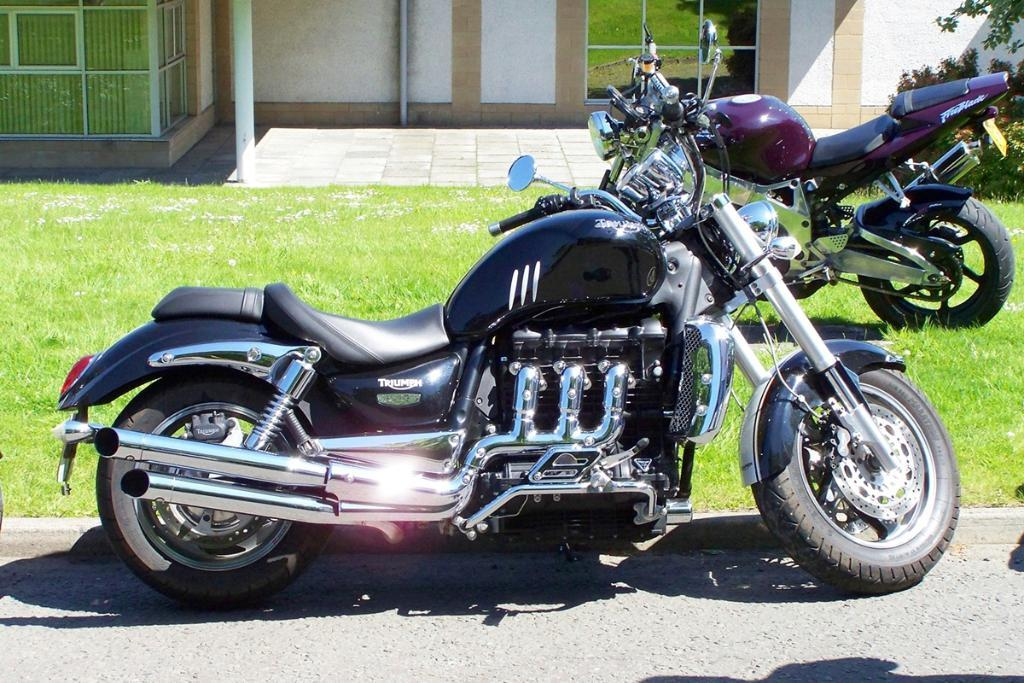How many bikes can be seen in the image? There are two bikes in the image. Where are the bikes located? The bikes are parked on the land in the image. What is the position of the bikes in the image? The bikes are in the middle of the picture. What type of vegetation is present on the ground? There is grass on the ground in the image. What can be seen in the background of the image? There is a wall in the background of the image. What type of patch is sewn onto the bikes in the image? There are no patches visible on the bikes in the image. Can you see any roses growing near the bikes in the image? There are no roses present in the image. 